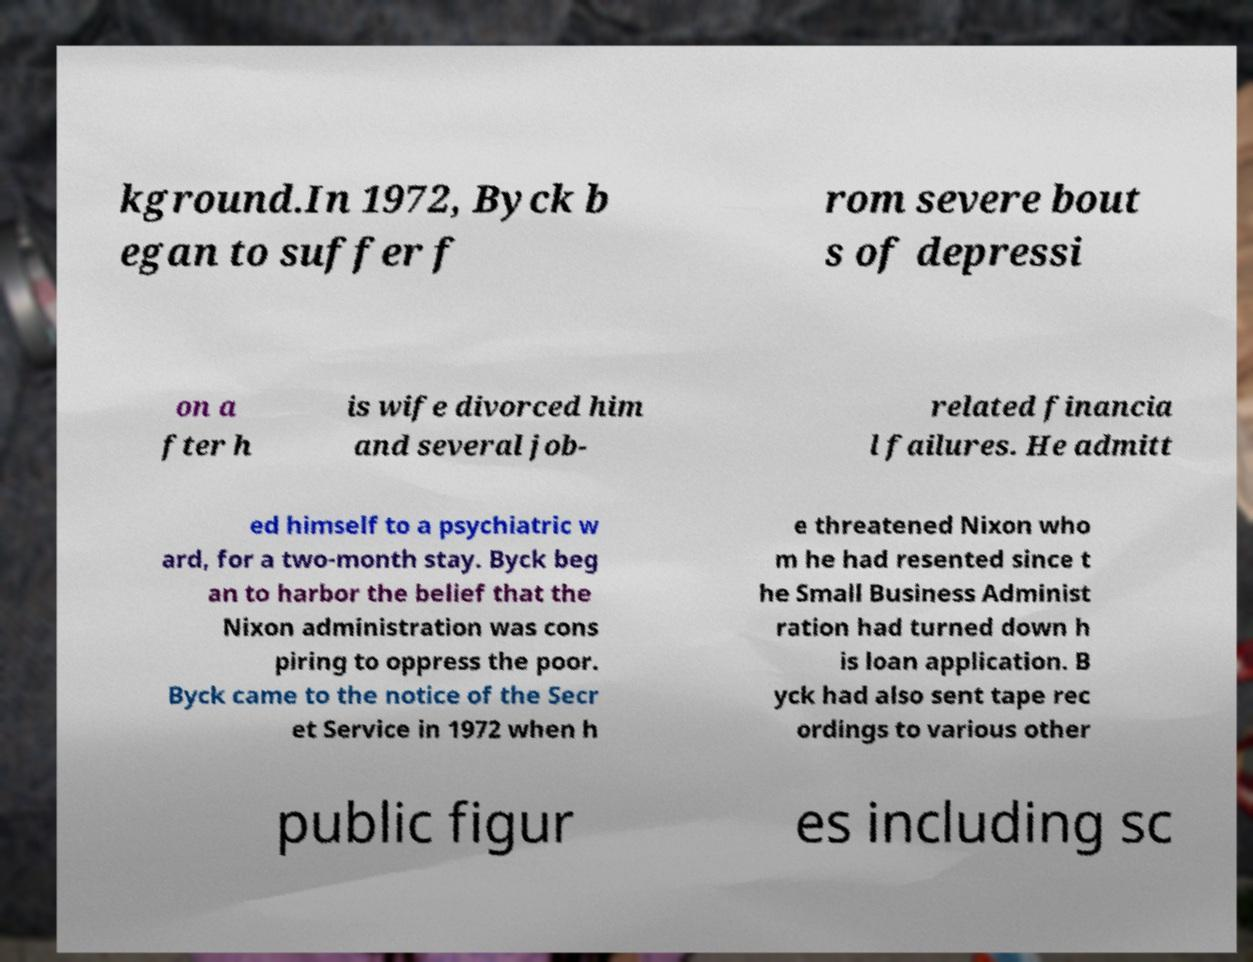Could you extract and type out the text from this image? kground.In 1972, Byck b egan to suffer f rom severe bout s of depressi on a fter h is wife divorced him and several job- related financia l failures. He admitt ed himself to a psychiatric w ard, for a two-month stay. Byck beg an to harbor the belief that the Nixon administration was cons piring to oppress the poor. Byck came to the notice of the Secr et Service in 1972 when h e threatened Nixon who m he had resented since t he Small Business Administ ration had turned down h is loan application. B yck had also sent tape rec ordings to various other public figur es including sc 